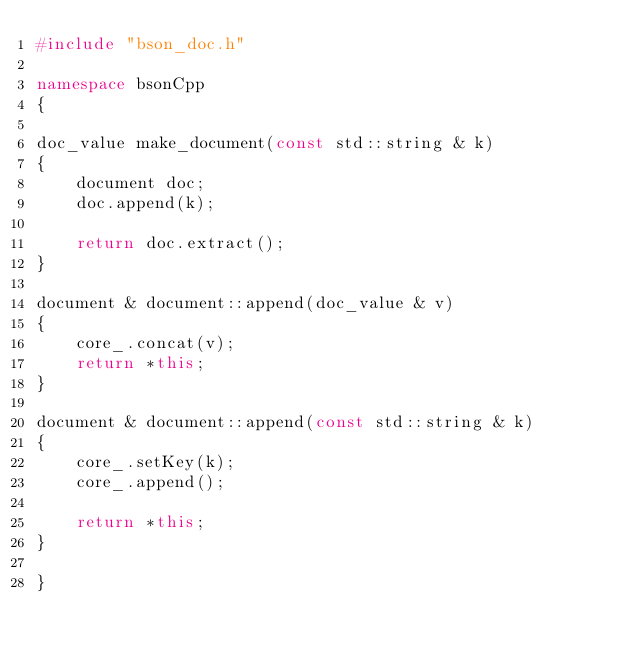<code> <loc_0><loc_0><loc_500><loc_500><_C++_>#include "bson_doc.h"

namespace bsonCpp
{

doc_value make_document(const std::string & k)
{
    document doc;
    doc.append(k);

    return doc.extract();
}

document & document::append(doc_value & v)
{
    core_.concat(v);
    return *this;
}

document & document::append(const std::string & k)
{
    core_.setKey(k);
    core_.append();

    return *this;
}

}</code> 